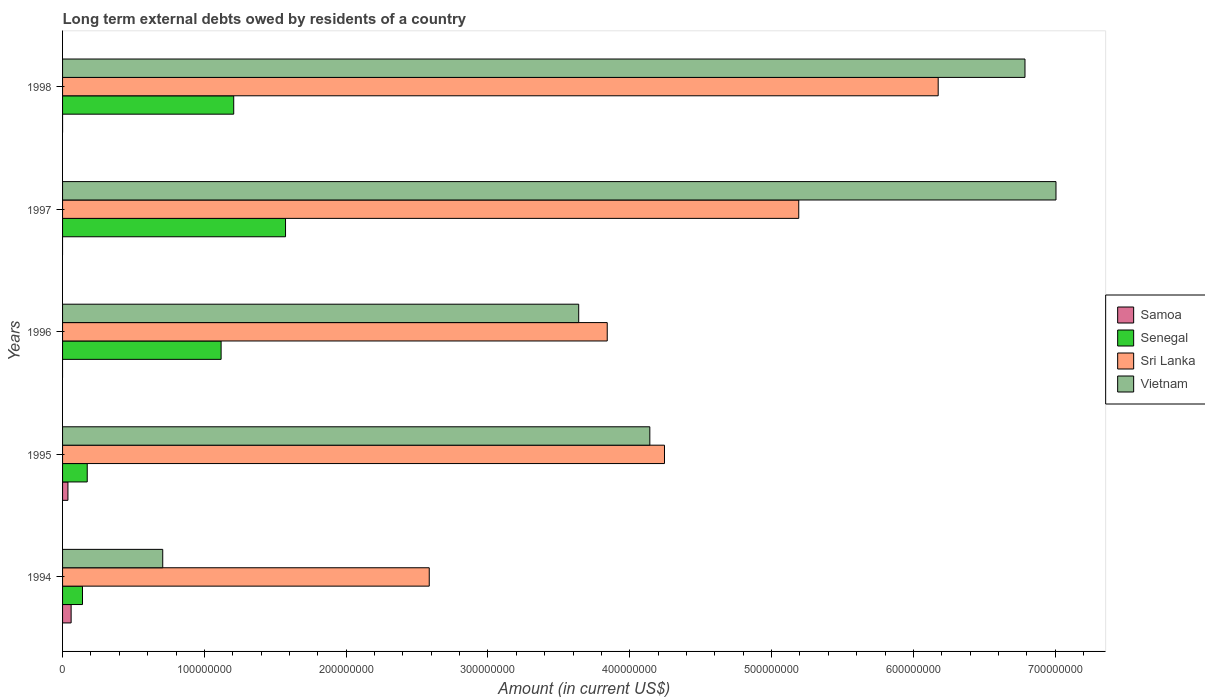How many groups of bars are there?
Your answer should be compact. 5. What is the label of the 1st group of bars from the top?
Ensure brevity in your answer.  1998. In how many cases, is the number of bars for a given year not equal to the number of legend labels?
Offer a very short reply. 3. What is the amount of long-term external debts owed by residents in Senegal in 1998?
Your answer should be compact. 1.21e+08. Across all years, what is the maximum amount of long-term external debts owed by residents in Vietnam?
Your answer should be very brief. 7.01e+08. Across all years, what is the minimum amount of long-term external debts owed by residents in Sri Lanka?
Provide a succinct answer. 2.59e+08. In which year was the amount of long-term external debts owed by residents in Vietnam maximum?
Provide a short and direct response. 1997. What is the total amount of long-term external debts owed by residents in Senegal in the graph?
Ensure brevity in your answer.  4.21e+08. What is the difference between the amount of long-term external debts owed by residents in Senegal in 1995 and that in 1997?
Make the answer very short. -1.40e+08. What is the difference between the amount of long-term external debts owed by residents in Senegal in 1994 and the amount of long-term external debts owed by residents in Samoa in 1998?
Ensure brevity in your answer.  1.41e+07. What is the average amount of long-term external debts owed by residents in Senegal per year?
Offer a very short reply. 8.42e+07. In the year 1997, what is the difference between the amount of long-term external debts owed by residents in Vietnam and amount of long-term external debts owed by residents in Senegal?
Provide a succinct answer. 5.43e+08. What is the ratio of the amount of long-term external debts owed by residents in Sri Lanka in 1994 to that in 1998?
Keep it short and to the point. 0.42. Is the amount of long-term external debts owed by residents in Vietnam in 1995 less than that in 1997?
Keep it short and to the point. Yes. What is the difference between the highest and the second highest amount of long-term external debts owed by residents in Vietnam?
Give a very brief answer. 2.19e+07. What is the difference between the highest and the lowest amount of long-term external debts owed by residents in Samoa?
Your response must be concise. 6.03e+06. Is it the case that in every year, the sum of the amount of long-term external debts owed by residents in Vietnam and amount of long-term external debts owed by residents in Sri Lanka is greater than the amount of long-term external debts owed by residents in Senegal?
Keep it short and to the point. Yes. How many bars are there?
Give a very brief answer. 17. What is the difference between two consecutive major ticks on the X-axis?
Your answer should be compact. 1.00e+08. Does the graph contain any zero values?
Your response must be concise. Yes. Where does the legend appear in the graph?
Offer a very short reply. Center right. What is the title of the graph?
Keep it short and to the point. Long term external debts owed by residents of a country. Does "India" appear as one of the legend labels in the graph?
Offer a terse response. No. What is the Amount (in current US$) of Samoa in 1994?
Provide a short and direct response. 6.03e+06. What is the Amount (in current US$) of Senegal in 1994?
Ensure brevity in your answer.  1.41e+07. What is the Amount (in current US$) of Sri Lanka in 1994?
Ensure brevity in your answer.  2.59e+08. What is the Amount (in current US$) in Vietnam in 1994?
Keep it short and to the point. 7.06e+07. What is the Amount (in current US$) in Samoa in 1995?
Provide a succinct answer. 3.79e+06. What is the Amount (in current US$) in Senegal in 1995?
Make the answer very short. 1.74e+07. What is the Amount (in current US$) in Sri Lanka in 1995?
Make the answer very short. 4.24e+08. What is the Amount (in current US$) in Vietnam in 1995?
Your response must be concise. 4.14e+08. What is the Amount (in current US$) in Samoa in 1996?
Give a very brief answer. 0. What is the Amount (in current US$) in Senegal in 1996?
Ensure brevity in your answer.  1.12e+08. What is the Amount (in current US$) in Sri Lanka in 1996?
Your answer should be compact. 3.84e+08. What is the Amount (in current US$) in Vietnam in 1996?
Your response must be concise. 3.64e+08. What is the Amount (in current US$) in Senegal in 1997?
Your response must be concise. 1.57e+08. What is the Amount (in current US$) in Sri Lanka in 1997?
Offer a very short reply. 5.19e+08. What is the Amount (in current US$) of Vietnam in 1997?
Offer a terse response. 7.01e+08. What is the Amount (in current US$) in Senegal in 1998?
Ensure brevity in your answer.  1.21e+08. What is the Amount (in current US$) in Sri Lanka in 1998?
Your answer should be compact. 6.17e+08. What is the Amount (in current US$) of Vietnam in 1998?
Provide a short and direct response. 6.79e+08. Across all years, what is the maximum Amount (in current US$) in Samoa?
Provide a succinct answer. 6.03e+06. Across all years, what is the maximum Amount (in current US$) of Senegal?
Your answer should be very brief. 1.57e+08. Across all years, what is the maximum Amount (in current US$) in Sri Lanka?
Ensure brevity in your answer.  6.17e+08. Across all years, what is the maximum Amount (in current US$) of Vietnam?
Offer a very short reply. 7.01e+08. Across all years, what is the minimum Amount (in current US$) of Samoa?
Provide a succinct answer. 0. Across all years, what is the minimum Amount (in current US$) in Senegal?
Give a very brief answer. 1.41e+07. Across all years, what is the minimum Amount (in current US$) in Sri Lanka?
Your response must be concise. 2.59e+08. Across all years, what is the minimum Amount (in current US$) in Vietnam?
Provide a short and direct response. 7.06e+07. What is the total Amount (in current US$) of Samoa in the graph?
Provide a succinct answer. 9.82e+06. What is the total Amount (in current US$) in Senegal in the graph?
Offer a terse response. 4.21e+08. What is the total Amount (in current US$) in Sri Lanka in the graph?
Ensure brevity in your answer.  2.20e+09. What is the total Amount (in current US$) in Vietnam in the graph?
Give a very brief answer. 2.23e+09. What is the difference between the Amount (in current US$) of Samoa in 1994 and that in 1995?
Keep it short and to the point. 2.24e+06. What is the difference between the Amount (in current US$) in Senegal in 1994 and that in 1995?
Offer a terse response. -3.34e+06. What is the difference between the Amount (in current US$) in Sri Lanka in 1994 and that in 1995?
Ensure brevity in your answer.  -1.66e+08. What is the difference between the Amount (in current US$) in Vietnam in 1994 and that in 1995?
Your answer should be compact. -3.43e+08. What is the difference between the Amount (in current US$) in Senegal in 1994 and that in 1996?
Offer a very short reply. -9.77e+07. What is the difference between the Amount (in current US$) in Sri Lanka in 1994 and that in 1996?
Offer a terse response. -1.26e+08. What is the difference between the Amount (in current US$) in Vietnam in 1994 and that in 1996?
Your answer should be compact. -2.93e+08. What is the difference between the Amount (in current US$) of Senegal in 1994 and that in 1997?
Offer a terse response. -1.43e+08. What is the difference between the Amount (in current US$) of Sri Lanka in 1994 and that in 1997?
Give a very brief answer. -2.61e+08. What is the difference between the Amount (in current US$) in Vietnam in 1994 and that in 1997?
Offer a terse response. -6.30e+08. What is the difference between the Amount (in current US$) of Senegal in 1994 and that in 1998?
Give a very brief answer. -1.07e+08. What is the difference between the Amount (in current US$) of Sri Lanka in 1994 and that in 1998?
Make the answer very short. -3.59e+08. What is the difference between the Amount (in current US$) in Vietnam in 1994 and that in 1998?
Provide a succinct answer. -6.08e+08. What is the difference between the Amount (in current US$) of Senegal in 1995 and that in 1996?
Offer a terse response. -9.44e+07. What is the difference between the Amount (in current US$) of Sri Lanka in 1995 and that in 1996?
Give a very brief answer. 4.04e+07. What is the difference between the Amount (in current US$) in Vietnam in 1995 and that in 1996?
Ensure brevity in your answer.  5.02e+07. What is the difference between the Amount (in current US$) in Senegal in 1995 and that in 1997?
Your answer should be very brief. -1.40e+08. What is the difference between the Amount (in current US$) of Sri Lanka in 1995 and that in 1997?
Provide a succinct answer. -9.47e+07. What is the difference between the Amount (in current US$) in Vietnam in 1995 and that in 1997?
Give a very brief answer. -2.86e+08. What is the difference between the Amount (in current US$) in Senegal in 1995 and that in 1998?
Your response must be concise. -1.03e+08. What is the difference between the Amount (in current US$) in Sri Lanka in 1995 and that in 1998?
Keep it short and to the point. -1.93e+08. What is the difference between the Amount (in current US$) of Vietnam in 1995 and that in 1998?
Make the answer very short. -2.65e+08. What is the difference between the Amount (in current US$) of Senegal in 1996 and that in 1997?
Provide a succinct answer. -4.54e+07. What is the difference between the Amount (in current US$) of Sri Lanka in 1996 and that in 1997?
Your response must be concise. -1.35e+08. What is the difference between the Amount (in current US$) of Vietnam in 1996 and that in 1997?
Make the answer very short. -3.37e+08. What is the difference between the Amount (in current US$) of Senegal in 1996 and that in 1998?
Provide a succinct answer. -8.89e+06. What is the difference between the Amount (in current US$) in Sri Lanka in 1996 and that in 1998?
Your answer should be compact. -2.33e+08. What is the difference between the Amount (in current US$) of Vietnam in 1996 and that in 1998?
Your response must be concise. -3.15e+08. What is the difference between the Amount (in current US$) of Senegal in 1997 and that in 1998?
Ensure brevity in your answer.  3.65e+07. What is the difference between the Amount (in current US$) of Sri Lanka in 1997 and that in 1998?
Your answer should be very brief. -9.83e+07. What is the difference between the Amount (in current US$) of Vietnam in 1997 and that in 1998?
Make the answer very short. 2.19e+07. What is the difference between the Amount (in current US$) in Samoa in 1994 and the Amount (in current US$) in Senegal in 1995?
Your answer should be very brief. -1.14e+07. What is the difference between the Amount (in current US$) of Samoa in 1994 and the Amount (in current US$) of Sri Lanka in 1995?
Offer a terse response. -4.18e+08. What is the difference between the Amount (in current US$) in Samoa in 1994 and the Amount (in current US$) in Vietnam in 1995?
Offer a very short reply. -4.08e+08. What is the difference between the Amount (in current US$) of Senegal in 1994 and the Amount (in current US$) of Sri Lanka in 1995?
Offer a terse response. -4.10e+08. What is the difference between the Amount (in current US$) of Senegal in 1994 and the Amount (in current US$) of Vietnam in 1995?
Offer a very short reply. -4.00e+08. What is the difference between the Amount (in current US$) in Sri Lanka in 1994 and the Amount (in current US$) in Vietnam in 1995?
Give a very brief answer. -1.56e+08. What is the difference between the Amount (in current US$) of Samoa in 1994 and the Amount (in current US$) of Senegal in 1996?
Your answer should be very brief. -1.06e+08. What is the difference between the Amount (in current US$) of Samoa in 1994 and the Amount (in current US$) of Sri Lanka in 1996?
Keep it short and to the point. -3.78e+08. What is the difference between the Amount (in current US$) in Samoa in 1994 and the Amount (in current US$) in Vietnam in 1996?
Make the answer very short. -3.58e+08. What is the difference between the Amount (in current US$) in Senegal in 1994 and the Amount (in current US$) in Sri Lanka in 1996?
Give a very brief answer. -3.70e+08. What is the difference between the Amount (in current US$) in Senegal in 1994 and the Amount (in current US$) in Vietnam in 1996?
Keep it short and to the point. -3.50e+08. What is the difference between the Amount (in current US$) of Sri Lanka in 1994 and the Amount (in current US$) of Vietnam in 1996?
Your response must be concise. -1.05e+08. What is the difference between the Amount (in current US$) in Samoa in 1994 and the Amount (in current US$) in Senegal in 1997?
Your answer should be compact. -1.51e+08. What is the difference between the Amount (in current US$) of Samoa in 1994 and the Amount (in current US$) of Sri Lanka in 1997?
Your answer should be compact. -5.13e+08. What is the difference between the Amount (in current US$) of Samoa in 1994 and the Amount (in current US$) of Vietnam in 1997?
Your answer should be compact. -6.95e+08. What is the difference between the Amount (in current US$) in Senegal in 1994 and the Amount (in current US$) in Sri Lanka in 1997?
Keep it short and to the point. -5.05e+08. What is the difference between the Amount (in current US$) in Senegal in 1994 and the Amount (in current US$) in Vietnam in 1997?
Give a very brief answer. -6.86e+08. What is the difference between the Amount (in current US$) of Sri Lanka in 1994 and the Amount (in current US$) of Vietnam in 1997?
Your answer should be compact. -4.42e+08. What is the difference between the Amount (in current US$) of Samoa in 1994 and the Amount (in current US$) of Senegal in 1998?
Ensure brevity in your answer.  -1.15e+08. What is the difference between the Amount (in current US$) of Samoa in 1994 and the Amount (in current US$) of Sri Lanka in 1998?
Make the answer very short. -6.11e+08. What is the difference between the Amount (in current US$) of Samoa in 1994 and the Amount (in current US$) of Vietnam in 1998?
Provide a short and direct response. -6.73e+08. What is the difference between the Amount (in current US$) of Senegal in 1994 and the Amount (in current US$) of Sri Lanka in 1998?
Your answer should be very brief. -6.03e+08. What is the difference between the Amount (in current US$) in Senegal in 1994 and the Amount (in current US$) in Vietnam in 1998?
Give a very brief answer. -6.65e+08. What is the difference between the Amount (in current US$) in Sri Lanka in 1994 and the Amount (in current US$) in Vietnam in 1998?
Make the answer very short. -4.20e+08. What is the difference between the Amount (in current US$) of Samoa in 1995 and the Amount (in current US$) of Senegal in 1996?
Ensure brevity in your answer.  -1.08e+08. What is the difference between the Amount (in current US$) in Samoa in 1995 and the Amount (in current US$) in Sri Lanka in 1996?
Keep it short and to the point. -3.80e+08. What is the difference between the Amount (in current US$) of Samoa in 1995 and the Amount (in current US$) of Vietnam in 1996?
Provide a short and direct response. -3.60e+08. What is the difference between the Amount (in current US$) in Senegal in 1995 and the Amount (in current US$) in Sri Lanka in 1996?
Offer a very short reply. -3.67e+08. What is the difference between the Amount (in current US$) of Senegal in 1995 and the Amount (in current US$) of Vietnam in 1996?
Your response must be concise. -3.47e+08. What is the difference between the Amount (in current US$) of Sri Lanka in 1995 and the Amount (in current US$) of Vietnam in 1996?
Make the answer very short. 6.05e+07. What is the difference between the Amount (in current US$) in Samoa in 1995 and the Amount (in current US$) in Senegal in 1997?
Offer a terse response. -1.53e+08. What is the difference between the Amount (in current US$) in Samoa in 1995 and the Amount (in current US$) in Sri Lanka in 1997?
Make the answer very short. -5.15e+08. What is the difference between the Amount (in current US$) of Samoa in 1995 and the Amount (in current US$) of Vietnam in 1997?
Ensure brevity in your answer.  -6.97e+08. What is the difference between the Amount (in current US$) of Senegal in 1995 and the Amount (in current US$) of Sri Lanka in 1997?
Your answer should be very brief. -5.02e+08. What is the difference between the Amount (in current US$) of Senegal in 1995 and the Amount (in current US$) of Vietnam in 1997?
Your response must be concise. -6.83e+08. What is the difference between the Amount (in current US$) in Sri Lanka in 1995 and the Amount (in current US$) in Vietnam in 1997?
Provide a succinct answer. -2.76e+08. What is the difference between the Amount (in current US$) in Samoa in 1995 and the Amount (in current US$) in Senegal in 1998?
Ensure brevity in your answer.  -1.17e+08. What is the difference between the Amount (in current US$) in Samoa in 1995 and the Amount (in current US$) in Sri Lanka in 1998?
Provide a succinct answer. -6.14e+08. What is the difference between the Amount (in current US$) of Samoa in 1995 and the Amount (in current US$) of Vietnam in 1998?
Offer a very short reply. -6.75e+08. What is the difference between the Amount (in current US$) in Senegal in 1995 and the Amount (in current US$) in Sri Lanka in 1998?
Ensure brevity in your answer.  -6.00e+08. What is the difference between the Amount (in current US$) of Senegal in 1995 and the Amount (in current US$) of Vietnam in 1998?
Make the answer very short. -6.61e+08. What is the difference between the Amount (in current US$) in Sri Lanka in 1995 and the Amount (in current US$) in Vietnam in 1998?
Offer a terse response. -2.54e+08. What is the difference between the Amount (in current US$) of Senegal in 1996 and the Amount (in current US$) of Sri Lanka in 1997?
Make the answer very short. -4.07e+08. What is the difference between the Amount (in current US$) in Senegal in 1996 and the Amount (in current US$) in Vietnam in 1997?
Your answer should be very brief. -5.89e+08. What is the difference between the Amount (in current US$) in Sri Lanka in 1996 and the Amount (in current US$) in Vietnam in 1997?
Offer a terse response. -3.16e+08. What is the difference between the Amount (in current US$) in Senegal in 1996 and the Amount (in current US$) in Sri Lanka in 1998?
Offer a terse response. -5.06e+08. What is the difference between the Amount (in current US$) in Senegal in 1996 and the Amount (in current US$) in Vietnam in 1998?
Keep it short and to the point. -5.67e+08. What is the difference between the Amount (in current US$) in Sri Lanka in 1996 and the Amount (in current US$) in Vietnam in 1998?
Your response must be concise. -2.95e+08. What is the difference between the Amount (in current US$) in Senegal in 1997 and the Amount (in current US$) in Sri Lanka in 1998?
Your answer should be very brief. -4.60e+08. What is the difference between the Amount (in current US$) of Senegal in 1997 and the Amount (in current US$) of Vietnam in 1998?
Provide a short and direct response. -5.21e+08. What is the difference between the Amount (in current US$) of Sri Lanka in 1997 and the Amount (in current US$) of Vietnam in 1998?
Offer a terse response. -1.60e+08. What is the average Amount (in current US$) of Samoa per year?
Make the answer very short. 1.96e+06. What is the average Amount (in current US$) of Senegal per year?
Keep it short and to the point. 8.42e+07. What is the average Amount (in current US$) of Sri Lanka per year?
Your response must be concise. 4.41e+08. What is the average Amount (in current US$) in Vietnam per year?
Your answer should be compact. 4.46e+08. In the year 1994, what is the difference between the Amount (in current US$) of Samoa and Amount (in current US$) of Senegal?
Keep it short and to the point. -8.02e+06. In the year 1994, what is the difference between the Amount (in current US$) of Samoa and Amount (in current US$) of Sri Lanka?
Your response must be concise. -2.53e+08. In the year 1994, what is the difference between the Amount (in current US$) of Samoa and Amount (in current US$) of Vietnam?
Provide a succinct answer. -6.46e+07. In the year 1994, what is the difference between the Amount (in current US$) of Senegal and Amount (in current US$) of Sri Lanka?
Give a very brief answer. -2.45e+08. In the year 1994, what is the difference between the Amount (in current US$) of Senegal and Amount (in current US$) of Vietnam?
Offer a very short reply. -5.66e+07. In the year 1994, what is the difference between the Amount (in current US$) in Sri Lanka and Amount (in current US$) in Vietnam?
Offer a very short reply. 1.88e+08. In the year 1995, what is the difference between the Amount (in current US$) of Samoa and Amount (in current US$) of Senegal?
Your response must be concise. -1.36e+07. In the year 1995, what is the difference between the Amount (in current US$) in Samoa and Amount (in current US$) in Sri Lanka?
Offer a terse response. -4.21e+08. In the year 1995, what is the difference between the Amount (in current US$) of Samoa and Amount (in current US$) of Vietnam?
Provide a short and direct response. -4.10e+08. In the year 1995, what is the difference between the Amount (in current US$) of Senegal and Amount (in current US$) of Sri Lanka?
Ensure brevity in your answer.  -4.07e+08. In the year 1995, what is the difference between the Amount (in current US$) in Senegal and Amount (in current US$) in Vietnam?
Your answer should be compact. -3.97e+08. In the year 1995, what is the difference between the Amount (in current US$) of Sri Lanka and Amount (in current US$) of Vietnam?
Keep it short and to the point. 1.03e+07. In the year 1996, what is the difference between the Amount (in current US$) of Senegal and Amount (in current US$) of Sri Lanka?
Keep it short and to the point. -2.72e+08. In the year 1996, what is the difference between the Amount (in current US$) of Senegal and Amount (in current US$) of Vietnam?
Offer a terse response. -2.52e+08. In the year 1996, what is the difference between the Amount (in current US$) in Sri Lanka and Amount (in current US$) in Vietnam?
Keep it short and to the point. 2.01e+07. In the year 1997, what is the difference between the Amount (in current US$) in Senegal and Amount (in current US$) in Sri Lanka?
Your response must be concise. -3.62e+08. In the year 1997, what is the difference between the Amount (in current US$) in Senegal and Amount (in current US$) in Vietnam?
Your response must be concise. -5.43e+08. In the year 1997, what is the difference between the Amount (in current US$) in Sri Lanka and Amount (in current US$) in Vietnam?
Your answer should be compact. -1.81e+08. In the year 1998, what is the difference between the Amount (in current US$) of Senegal and Amount (in current US$) of Sri Lanka?
Your response must be concise. -4.97e+08. In the year 1998, what is the difference between the Amount (in current US$) in Senegal and Amount (in current US$) in Vietnam?
Offer a very short reply. -5.58e+08. In the year 1998, what is the difference between the Amount (in current US$) of Sri Lanka and Amount (in current US$) of Vietnam?
Keep it short and to the point. -6.12e+07. What is the ratio of the Amount (in current US$) in Samoa in 1994 to that in 1995?
Provide a short and direct response. 1.59. What is the ratio of the Amount (in current US$) of Senegal in 1994 to that in 1995?
Your answer should be compact. 0.81. What is the ratio of the Amount (in current US$) of Sri Lanka in 1994 to that in 1995?
Your response must be concise. 0.61. What is the ratio of the Amount (in current US$) in Vietnam in 1994 to that in 1995?
Provide a short and direct response. 0.17. What is the ratio of the Amount (in current US$) of Senegal in 1994 to that in 1996?
Offer a terse response. 0.13. What is the ratio of the Amount (in current US$) of Sri Lanka in 1994 to that in 1996?
Your response must be concise. 0.67. What is the ratio of the Amount (in current US$) of Vietnam in 1994 to that in 1996?
Provide a short and direct response. 0.19. What is the ratio of the Amount (in current US$) of Senegal in 1994 to that in 1997?
Your answer should be very brief. 0.09. What is the ratio of the Amount (in current US$) in Sri Lanka in 1994 to that in 1997?
Keep it short and to the point. 0.5. What is the ratio of the Amount (in current US$) of Vietnam in 1994 to that in 1997?
Make the answer very short. 0.1. What is the ratio of the Amount (in current US$) of Senegal in 1994 to that in 1998?
Offer a very short reply. 0.12. What is the ratio of the Amount (in current US$) in Sri Lanka in 1994 to that in 1998?
Keep it short and to the point. 0.42. What is the ratio of the Amount (in current US$) of Vietnam in 1994 to that in 1998?
Your answer should be very brief. 0.1. What is the ratio of the Amount (in current US$) of Senegal in 1995 to that in 1996?
Keep it short and to the point. 0.16. What is the ratio of the Amount (in current US$) of Sri Lanka in 1995 to that in 1996?
Ensure brevity in your answer.  1.11. What is the ratio of the Amount (in current US$) of Vietnam in 1995 to that in 1996?
Provide a short and direct response. 1.14. What is the ratio of the Amount (in current US$) of Senegal in 1995 to that in 1997?
Make the answer very short. 0.11. What is the ratio of the Amount (in current US$) of Sri Lanka in 1995 to that in 1997?
Provide a succinct answer. 0.82. What is the ratio of the Amount (in current US$) in Vietnam in 1995 to that in 1997?
Provide a short and direct response. 0.59. What is the ratio of the Amount (in current US$) in Senegal in 1995 to that in 1998?
Keep it short and to the point. 0.14. What is the ratio of the Amount (in current US$) in Sri Lanka in 1995 to that in 1998?
Keep it short and to the point. 0.69. What is the ratio of the Amount (in current US$) in Vietnam in 1995 to that in 1998?
Provide a short and direct response. 0.61. What is the ratio of the Amount (in current US$) of Senegal in 1996 to that in 1997?
Give a very brief answer. 0.71. What is the ratio of the Amount (in current US$) of Sri Lanka in 1996 to that in 1997?
Your answer should be compact. 0.74. What is the ratio of the Amount (in current US$) of Vietnam in 1996 to that in 1997?
Keep it short and to the point. 0.52. What is the ratio of the Amount (in current US$) in Senegal in 1996 to that in 1998?
Your answer should be compact. 0.93. What is the ratio of the Amount (in current US$) of Sri Lanka in 1996 to that in 1998?
Make the answer very short. 0.62. What is the ratio of the Amount (in current US$) in Vietnam in 1996 to that in 1998?
Offer a very short reply. 0.54. What is the ratio of the Amount (in current US$) in Senegal in 1997 to that in 1998?
Your answer should be very brief. 1.3. What is the ratio of the Amount (in current US$) of Sri Lanka in 1997 to that in 1998?
Your response must be concise. 0.84. What is the ratio of the Amount (in current US$) in Vietnam in 1997 to that in 1998?
Your answer should be very brief. 1.03. What is the difference between the highest and the second highest Amount (in current US$) of Senegal?
Your answer should be compact. 3.65e+07. What is the difference between the highest and the second highest Amount (in current US$) of Sri Lanka?
Your answer should be very brief. 9.83e+07. What is the difference between the highest and the second highest Amount (in current US$) in Vietnam?
Your answer should be compact. 2.19e+07. What is the difference between the highest and the lowest Amount (in current US$) in Samoa?
Your response must be concise. 6.03e+06. What is the difference between the highest and the lowest Amount (in current US$) of Senegal?
Make the answer very short. 1.43e+08. What is the difference between the highest and the lowest Amount (in current US$) in Sri Lanka?
Your answer should be compact. 3.59e+08. What is the difference between the highest and the lowest Amount (in current US$) in Vietnam?
Your answer should be compact. 6.30e+08. 